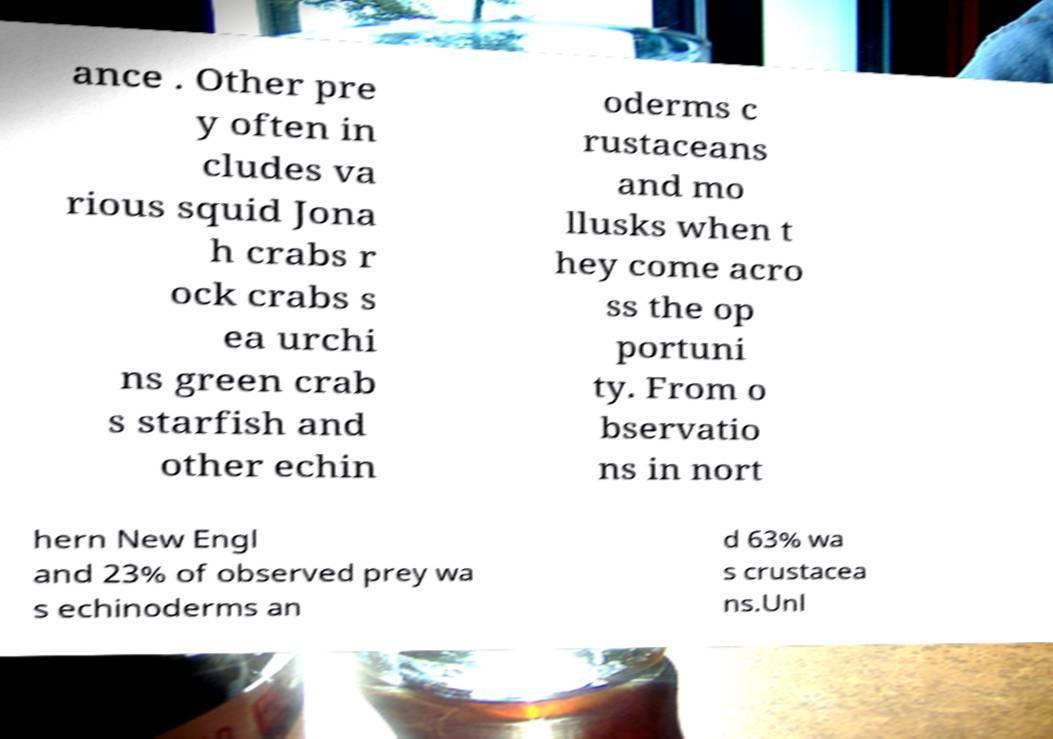Can you read and provide the text displayed in the image?This photo seems to have some interesting text. Can you extract and type it out for me? ance . Other pre y often in cludes va rious squid Jona h crabs r ock crabs s ea urchi ns green crab s starfish and other echin oderms c rustaceans and mo llusks when t hey come acro ss the op portuni ty. From o bservatio ns in nort hern New Engl and 23% of observed prey wa s echinoderms an d 63% wa s crustacea ns.Unl 